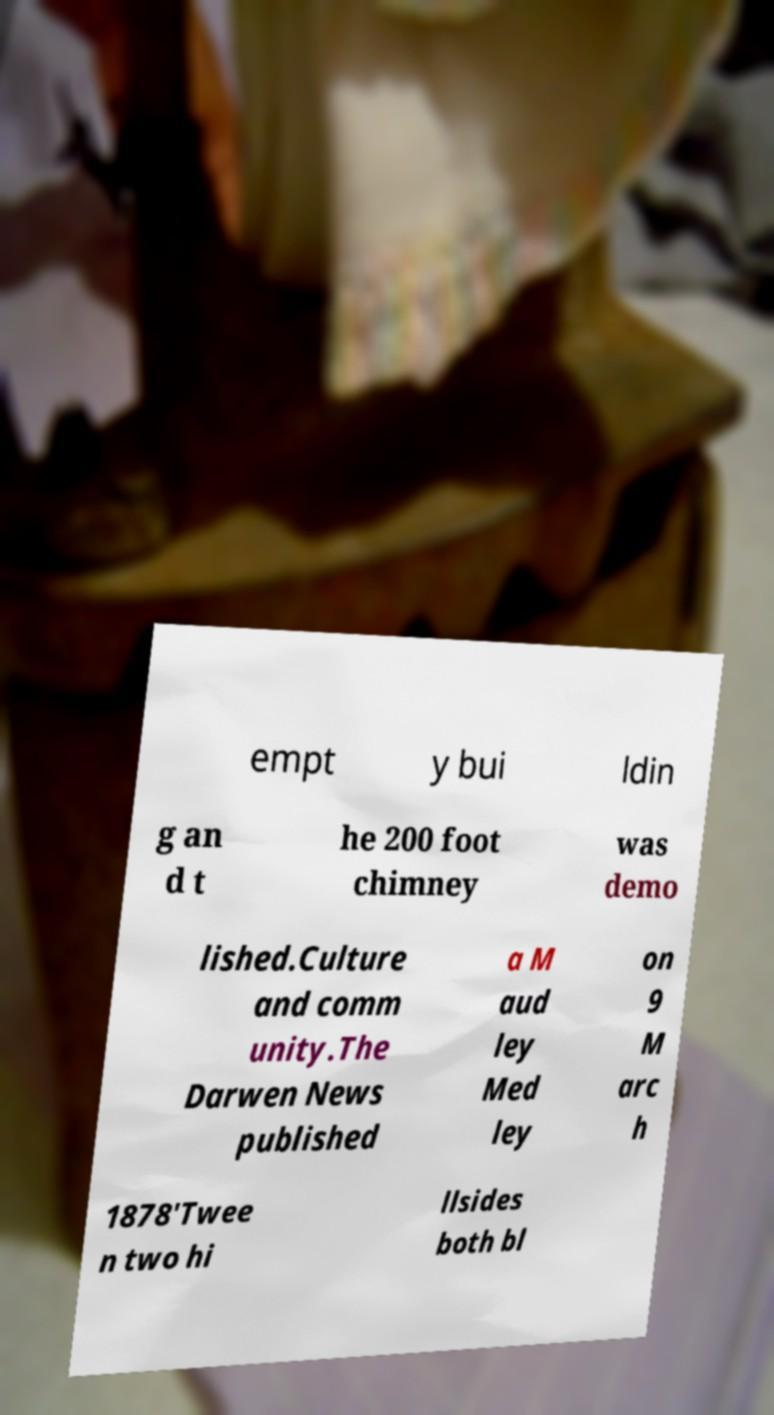Can you read and provide the text displayed in the image?This photo seems to have some interesting text. Can you extract and type it out for me? empt y bui ldin g an d t he 200 foot chimney was demo lished.Culture and comm unity.The Darwen News published a M aud ley Med ley on 9 M arc h 1878'Twee n two hi llsides both bl 